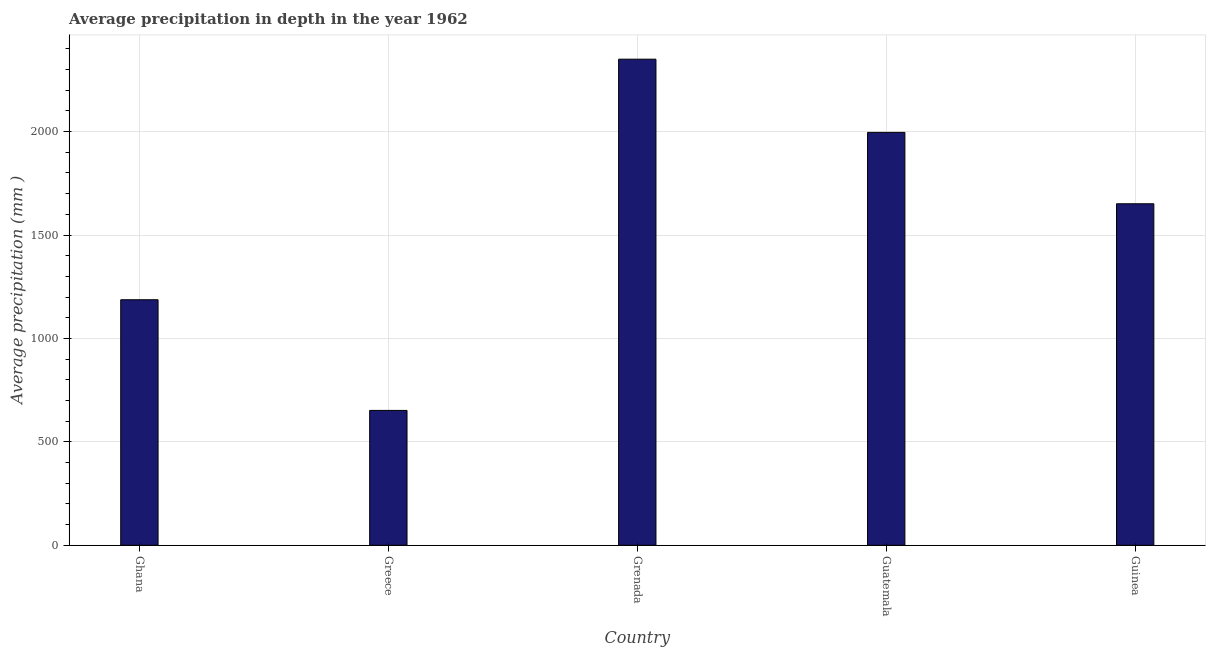Does the graph contain grids?
Offer a very short reply. Yes. What is the title of the graph?
Ensure brevity in your answer.  Average precipitation in depth in the year 1962. What is the label or title of the Y-axis?
Keep it short and to the point. Average precipitation (mm ). What is the average precipitation in depth in Greece?
Keep it short and to the point. 652. Across all countries, what is the maximum average precipitation in depth?
Give a very brief answer. 2350. Across all countries, what is the minimum average precipitation in depth?
Provide a short and direct response. 652. In which country was the average precipitation in depth maximum?
Give a very brief answer. Grenada. What is the sum of the average precipitation in depth?
Provide a succinct answer. 7836. What is the difference between the average precipitation in depth in Ghana and Guatemala?
Your answer should be compact. -809. What is the average average precipitation in depth per country?
Make the answer very short. 1567. What is the median average precipitation in depth?
Give a very brief answer. 1651. What is the ratio of the average precipitation in depth in Ghana to that in Grenada?
Make the answer very short. 0.51. Is the average precipitation in depth in Grenada less than that in Guinea?
Offer a very short reply. No. What is the difference between the highest and the second highest average precipitation in depth?
Your answer should be very brief. 354. What is the difference between the highest and the lowest average precipitation in depth?
Provide a short and direct response. 1698. In how many countries, is the average precipitation in depth greater than the average average precipitation in depth taken over all countries?
Offer a terse response. 3. What is the difference between two consecutive major ticks on the Y-axis?
Provide a succinct answer. 500. Are the values on the major ticks of Y-axis written in scientific E-notation?
Provide a short and direct response. No. What is the Average precipitation (mm ) of Ghana?
Make the answer very short. 1187. What is the Average precipitation (mm ) of Greece?
Your answer should be compact. 652. What is the Average precipitation (mm ) of Grenada?
Your answer should be very brief. 2350. What is the Average precipitation (mm ) of Guatemala?
Your answer should be compact. 1996. What is the Average precipitation (mm ) in Guinea?
Make the answer very short. 1651. What is the difference between the Average precipitation (mm ) in Ghana and Greece?
Provide a short and direct response. 535. What is the difference between the Average precipitation (mm ) in Ghana and Grenada?
Ensure brevity in your answer.  -1163. What is the difference between the Average precipitation (mm ) in Ghana and Guatemala?
Your answer should be compact. -809. What is the difference between the Average precipitation (mm ) in Ghana and Guinea?
Your response must be concise. -464. What is the difference between the Average precipitation (mm ) in Greece and Grenada?
Offer a terse response. -1698. What is the difference between the Average precipitation (mm ) in Greece and Guatemala?
Give a very brief answer. -1344. What is the difference between the Average precipitation (mm ) in Greece and Guinea?
Offer a very short reply. -999. What is the difference between the Average precipitation (mm ) in Grenada and Guatemala?
Provide a succinct answer. 354. What is the difference between the Average precipitation (mm ) in Grenada and Guinea?
Your response must be concise. 699. What is the difference between the Average precipitation (mm ) in Guatemala and Guinea?
Offer a very short reply. 345. What is the ratio of the Average precipitation (mm ) in Ghana to that in Greece?
Provide a succinct answer. 1.82. What is the ratio of the Average precipitation (mm ) in Ghana to that in Grenada?
Your response must be concise. 0.51. What is the ratio of the Average precipitation (mm ) in Ghana to that in Guatemala?
Your answer should be compact. 0.59. What is the ratio of the Average precipitation (mm ) in Ghana to that in Guinea?
Make the answer very short. 0.72. What is the ratio of the Average precipitation (mm ) in Greece to that in Grenada?
Your response must be concise. 0.28. What is the ratio of the Average precipitation (mm ) in Greece to that in Guatemala?
Offer a very short reply. 0.33. What is the ratio of the Average precipitation (mm ) in Greece to that in Guinea?
Keep it short and to the point. 0.4. What is the ratio of the Average precipitation (mm ) in Grenada to that in Guatemala?
Your answer should be compact. 1.18. What is the ratio of the Average precipitation (mm ) in Grenada to that in Guinea?
Offer a very short reply. 1.42. What is the ratio of the Average precipitation (mm ) in Guatemala to that in Guinea?
Give a very brief answer. 1.21. 